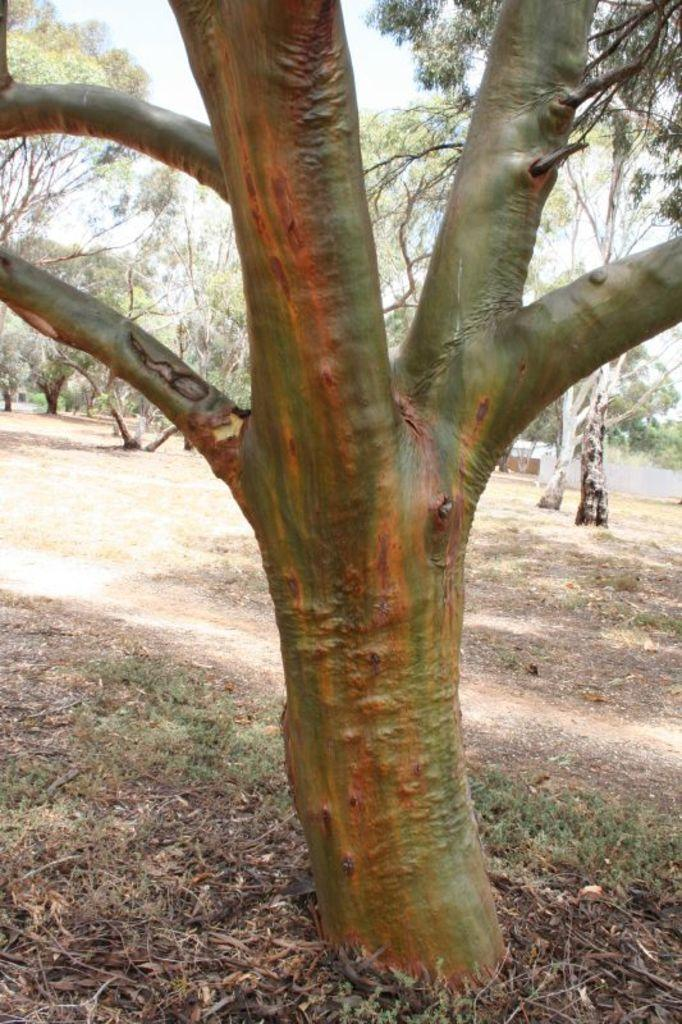What is the main object on the ground surface in the image? There is a tree trunk on the ground surface in the image. What type of vegetation is near the tree trunk? There is dried grass near the tree trunk. How many trees can be seen in the image? There are many trees visible in the image. What part of the natural environment is visible in the image? A part of the sky is visible in the image. What type of room is visible in the image? There is no room visible in the image; it features a tree trunk, dried grass, and many trees in an outdoor setting. What type of voyage is being depicted in the image? There is no voyage depicted in the image; it shows a tree trunk, dried grass, and many trees in an outdoor setting. 